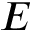Convert formula to latex. <formula><loc_0><loc_0><loc_500><loc_500>E</formula> 